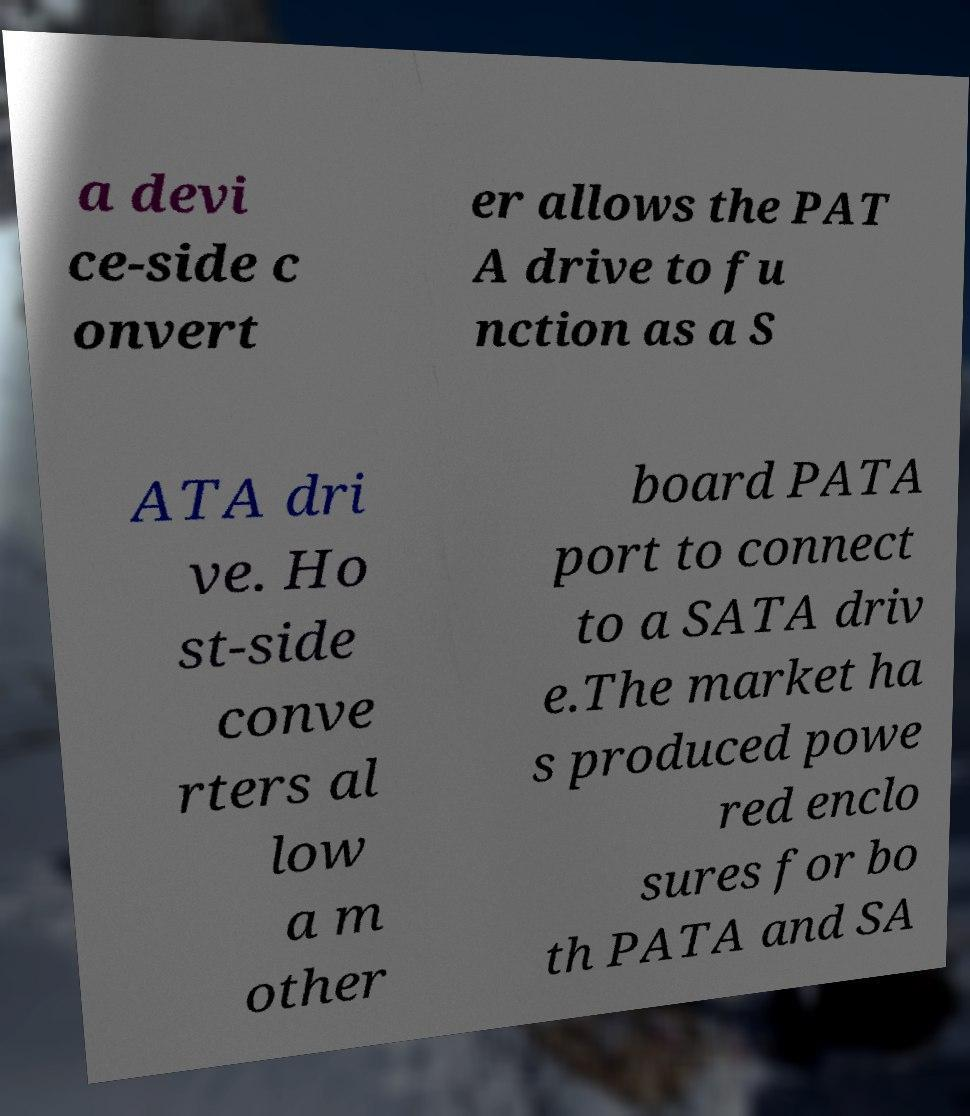Could you assist in decoding the text presented in this image and type it out clearly? a devi ce-side c onvert er allows the PAT A drive to fu nction as a S ATA dri ve. Ho st-side conve rters al low a m other board PATA port to connect to a SATA driv e.The market ha s produced powe red enclo sures for bo th PATA and SA 